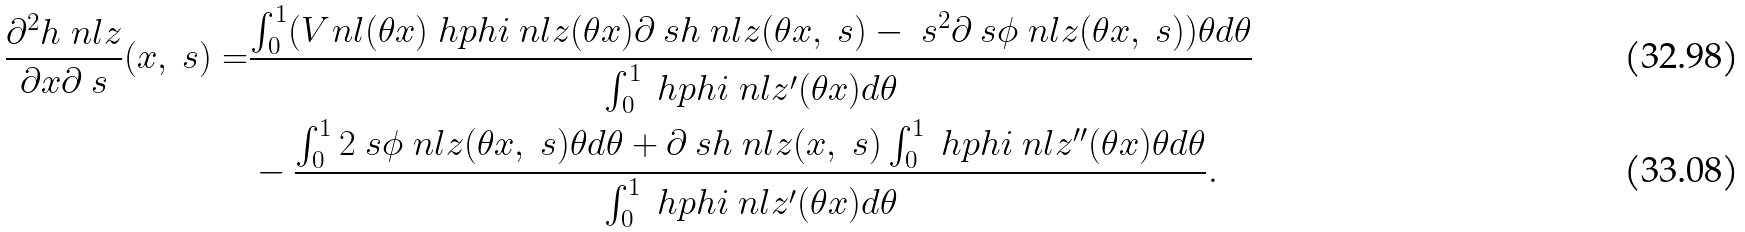<formula> <loc_0><loc_0><loc_500><loc_500>\frac { \partial ^ { 2 } h _ { \ } n l z } { \partial x \partial \ s } ( x , \ s ) = & \frac { \int _ { 0 } ^ { 1 } ( V _ { \ } n l ( \theta x ) \ h p h i _ { \ } n l z ( \theta x ) \partial _ { \ } s h _ { \ } n l z ( \theta x , \ s ) - \ s ^ { 2 } \partial _ { \ } s \phi _ { \ } n l z ( \theta x , \ s ) ) \theta d \theta } { \int _ { 0 } ^ { 1 } \ h p h i _ { \ } n l z ^ { \prime } ( \theta x ) d \theta } \\ & - \frac { \int _ { 0 } ^ { 1 } 2 \ s \phi _ { \ } n l z ( \theta x , \ s ) \theta d \theta + \partial _ { \ } s h _ { \ } n l z ( x , \ s ) \int _ { 0 } ^ { 1 } \ h p h i _ { \ } n l z ^ { \prime \prime } ( \theta x ) \theta d \theta } { \int _ { 0 } ^ { 1 } \ h p h i _ { \ } n l z ^ { \prime } ( \theta x ) d \theta } .</formula> 